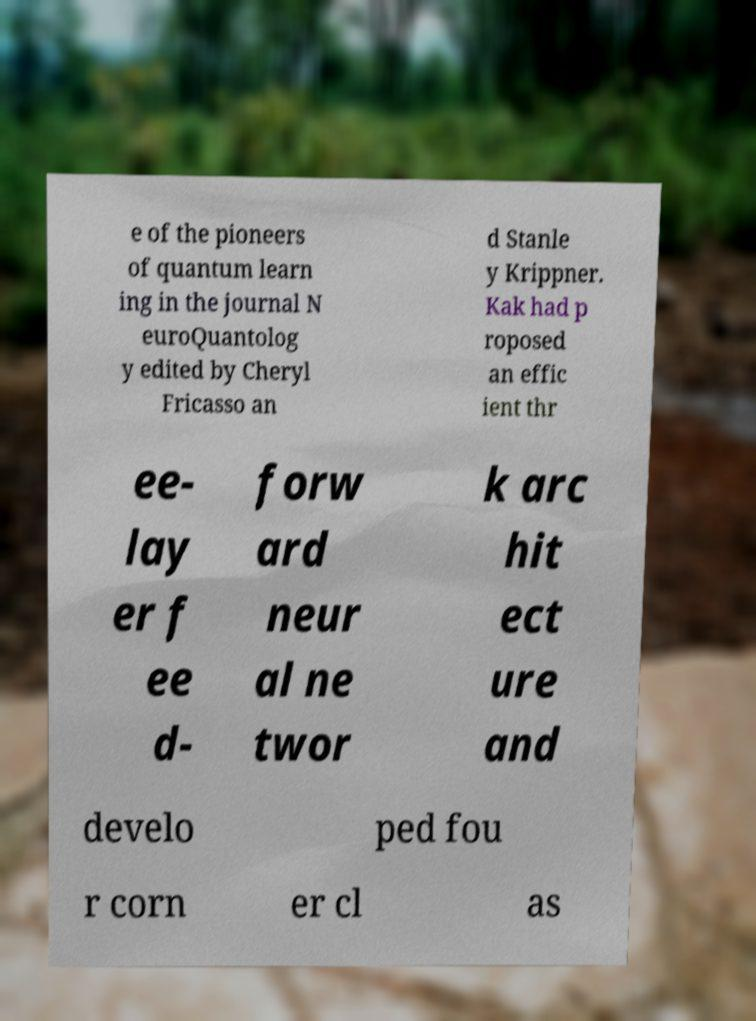Can you read and provide the text displayed in the image?This photo seems to have some interesting text. Can you extract and type it out for me? e of the pioneers of quantum learn ing in the journal N euroQuantolog y edited by Cheryl Fricasso an d Stanle y Krippner. Kak had p roposed an effic ient thr ee- lay er f ee d- forw ard neur al ne twor k arc hit ect ure and develo ped fou r corn er cl as 